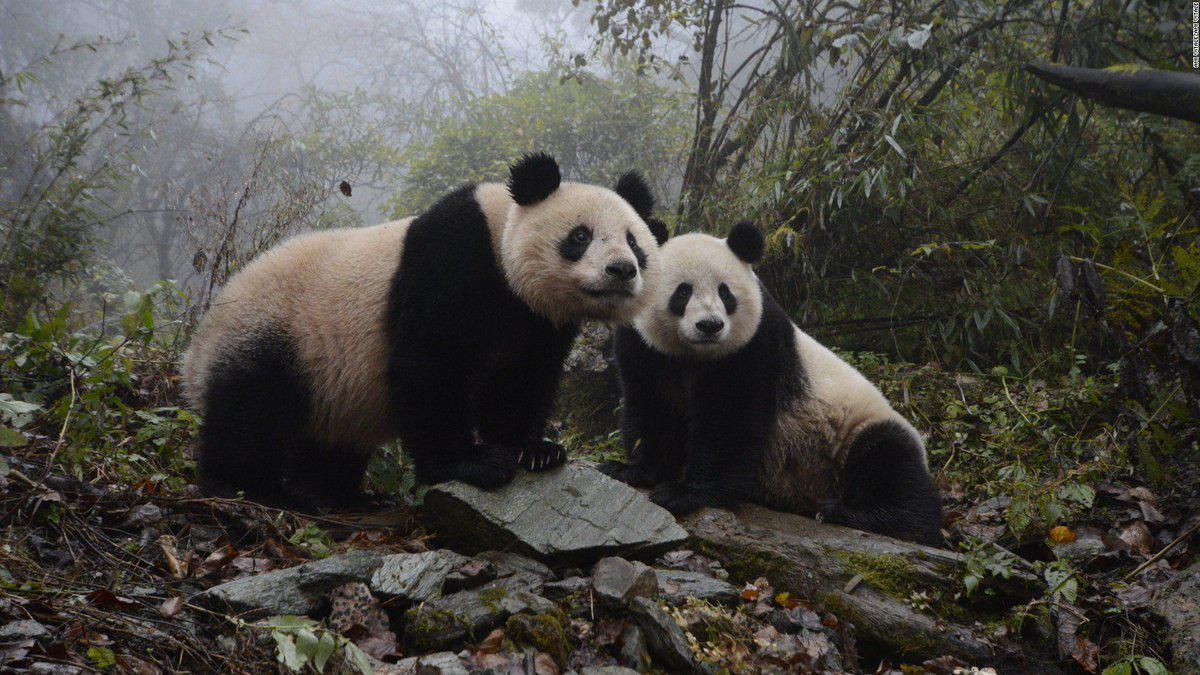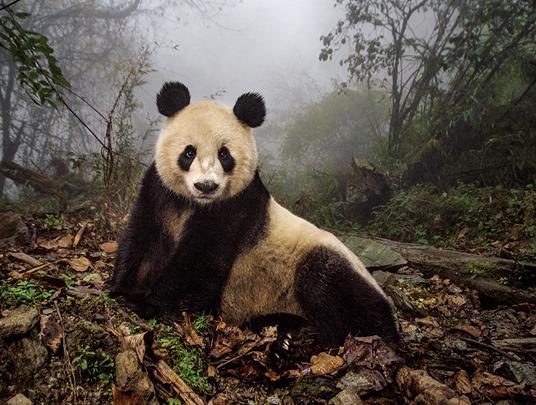The first image is the image on the left, the second image is the image on the right. Given the left and right images, does the statement "The left and right image contains the same number of pandas." hold true? Answer yes or no. No. The first image is the image on the left, the second image is the image on the right. Given the left and right images, does the statement "A panda is laying on its back." hold true? Answer yes or no. No. 